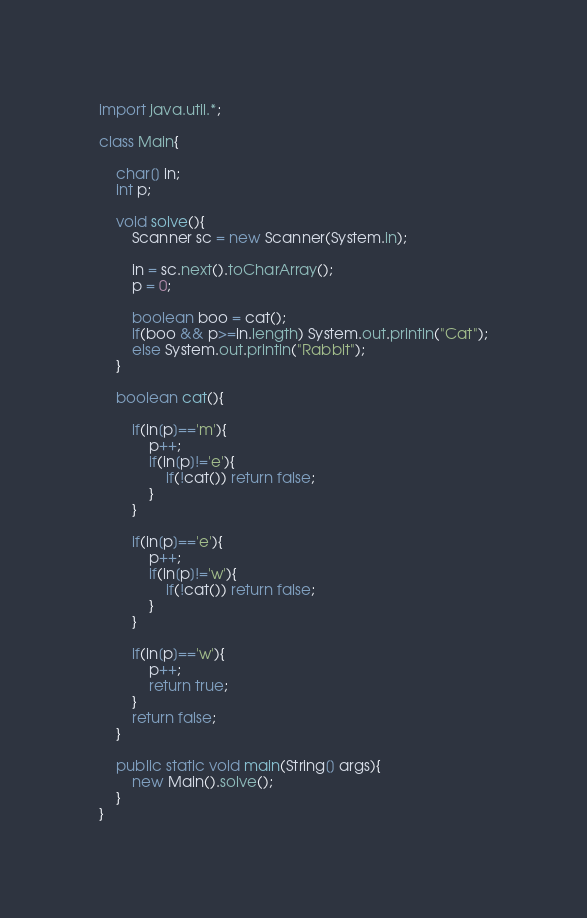Convert code to text. <code><loc_0><loc_0><loc_500><loc_500><_Java_>import java.util.*;

class Main{

    char[] in;
    int p;

    void solve(){
        Scanner sc = new Scanner(System.in);

        in = sc.next().toCharArray();
        p = 0;

        boolean boo = cat();
        if(boo && p>=in.length) System.out.println("Cat");
        else System.out.println("Rabbit");
    }

    boolean cat(){

        if(in[p]=='m'){
            p++;
            if(in[p]!='e'){
                if(!cat()) return false;
            }
        }

        if(in[p]=='e'){
            p++;
            if(in[p]!='w'){
                if(!cat()) return false;
            }
        }
        
        if(in[p]=='w'){
            p++;
            return true;
        }
        return false;
    }

    public static void main(String[] args){
        new Main().solve();
    }
}</code> 